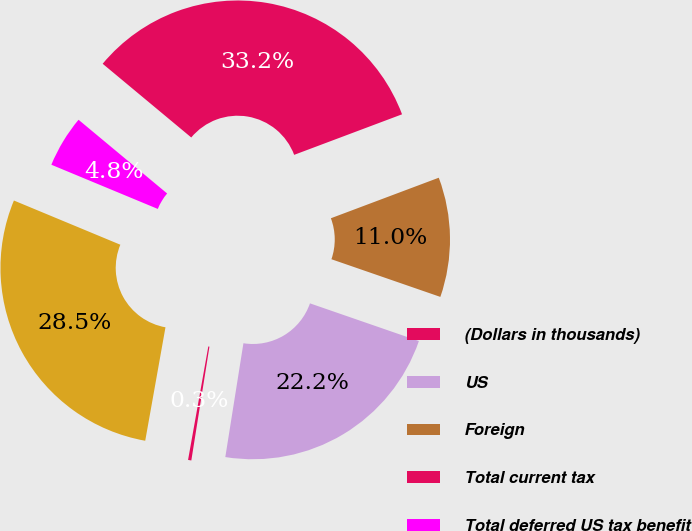Convert chart to OTSL. <chart><loc_0><loc_0><loc_500><loc_500><pie_chart><fcel>(Dollars in thousands)<fcel>US<fcel>Foreign<fcel>Total current tax<fcel>Total deferred US tax benefit<fcel>Total income tax expense<nl><fcel>0.3%<fcel>22.21%<fcel>11.02%<fcel>33.23%<fcel>4.78%<fcel>28.45%<nl></chart> 